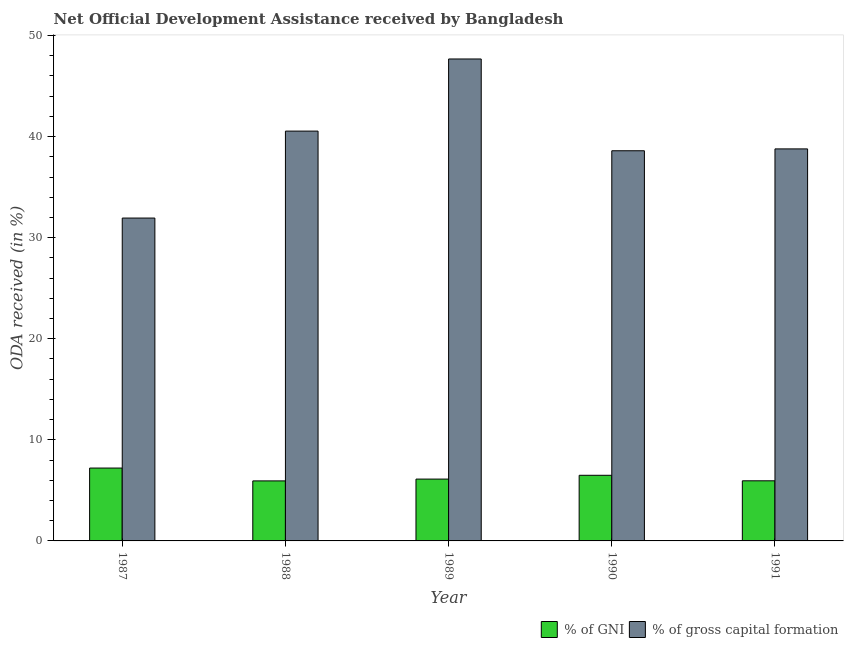How many different coloured bars are there?
Provide a short and direct response. 2. How many groups of bars are there?
Give a very brief answer. 5. How many bars are there on the 1st tick from the right?
Your answer should be very brief. 2. In how many cases, is the number of bars for a given year not equal to the number of legend labels?
Keep it short and to the point. 0. What is the oda received as percentage of gni in 1989?
Make the answer very short. 6.12. Across all years, what is the maximum oda received as percentage of gross capital formation?
Your answer should be very brief. 47.68. Across all years, what is the minimum oda received as percentage of gni?
Provide a succinct answer. 5.94. In which year was the oda received as percentage of gross capital formation maximum?
Ensure brevity in your answer.  1989. In which year was the oda received as percentage of gni minimum?
Your answer should be very brief. 1988. What is the total oda received as percentage of gross capital formation in the graph?
Keep it short and to the point. 197.54. What is the difference between the oda received as percentage of gross capital formation in 1990 and that in 1991?
Keep it short and to the point. -0.18. What is the difference between the oda received as percentage of gni in 1990 and the oda received as percentage of gross capital formation in 1989?
Provide a short and direct response. 0.38. What is the average oda received as percentage of gni per year?
Make the answer very short. 6.34. In the year 1991, what is the difference between the oda received as percentage of gross capital formation and oda received as percentage of gni?
Your answer should be very brief. 0. What is the ratio of the oda received as percentage of gni in 1989 to that in 1990?
Give a very brief answer. 0.94. Is the difference between the oda received as percentage of gni in 1987 and 1990 greater than the difference between the oda received as percentage of gross capital formation in 1987 and 1990?
Keep it short and to the point. No. What is the difference between the highest and the second highest oda received as percentage of gross capital formation?
Provide a succinct answer. 7.14. What is the difference between the highest and the lowest oda received as percentage of gni?
Provide a short and direct response. 1.27. In how many years, is the oda received as percentage of gross capital formation greater than the average oda received as percentage of gross capital formation taken over all years?
Your answer should be compact. 2. Is the sum of the oda received as percentage of gni in 1988 and 1990 greater than the maximum oda received as percentage of gross capital formation across all years?
Provide a short and direct response. Yes. What does the 2nd bar from the left in 1987 represents?
Your answer should be compact. % of gross capital formation. What does the 1st bar from the right in 1991 represents?
Offer a terse response. % of gross capital formation. Are all the bars in the graph horizontal?
Provide a succinct answer. No. Does the graph contain any zero values?
Make the answer very short. No. How many legend labels are there?
Your response must be concise. 2. What is the title of the graph?
Your response must be concise. Net Official Development Assistance received by Bangladesh. What is the label or title of the X-axis?
Your response must be concise. Year. What is the label or title of the Y-axis?
Your answer should be very brief. ODA received (in %). What is the ODA received (in %) in % of GNI in 1987?
Give a very brief answer. 7.21. What is the ODA received (in %) in % of gross capital formation in 1987?
Offer a very short reply. 31.94. What is the ODA received (in %) in % of GNI in 1988?
Make the answer very short. 5.94. What is the ODA received (in %) in % of gross capital formation in 1988?
Provide a succinct answer. 40.54. What is the ODA received (in %) in % of GNI in 1989?
Offer a terse response. 6.12. What is the ODA received (in %) in % of gross capital formation in 1989?
Your answer should be compact. 47.68. What is the ODA received (in %) of % of GNI in 1990?
Provide a succinct answer. 6.49. What is the ODA received (in %) of % of gross capital formation in 1990?
Provide a succinct answer. 38.6. What is the ODA received (in %) of % of GNI in 1991?
Make the answer very short. 5.95. What is the ODA received (in %) in % of gross capital formation in 1991?
Your response must be concise. 38.78. Across all years, what is the maximum ODA received (in %) in % of GNI?
Provide a succinct answer. 7.21. Across all years, what is the maximum ODA received (in %) in % of gross capital formation?
Provide a succinct answer. 47.68. Across all years, what is the minimum ODA received (in %) of % of GNI?
Provide a short and direct response. 5.94. Across all years, what is the minimum ODA received (in %) of % of gross capital formation?
Provide a succinct answer. 31.94. What is the total ODA received (in %) in % of GNI in the graph?
Your answer should be very brief. 31.7. What is the total ODA received (in %) of % of gross capital formation in the graph?
Your answer should be very brief. 197.54. What is the difference between the ODA received (in %) in % of GNI in 1987 and that in 1988?
Offer a terse response. 1.27. What is the difference between the ODA received (in %) in % of gross capital formation in 1987 and that in 1988?
Keep it short and to the point. -8.6. What is the difference between the ODA received (in %) of % of GNI in 1987 and that in 1989?
Give a very brief answer. 1.09. What is the difference between the ODA received (in %) in % of gross capital formation in 1987 and that in 1989?
Offer a terse response. -15.74. What is the difference between the ODA received (in %) of % of GNI in 1987 and that in 1990?
Provide a short and direct response. 0.72. What is the difference between the ODA received (in %) of % of gross capital formation in 1987 and that in 1990?
Provide a succinct answer. -6.66. What is the difference between the ODA received (in %) of % of GNI in 1987 and that in 1991?
Ensure brevity in your answer.  1.26. What is the difference between the ODA received (in %) of % of gross capital formation in 1987 and that in 1991?
Provide a short and direct response. -6.84. What is the difference between the ODA received (in %) in % of GNI in 1988 and that in 1989?
Your response must be concise. -0.18. What is the difference between the ODA received (in %) of % of gross capital formation in 1988 and that in 1989?
Provide a succinct answer. -7.14. What is the difference between the ODA received (in %) in % of GNI in 1988 and that in 1990?
Offer a very short reply. -0.55. What is the difference between the ODA received (in %) in % of gross capital formation in 1988 and that in 1990?
Ensure brevity in your answer.  1.95. What is the difference between the ODA received (in %) of % of GNI in 1988 and that in 1991?
Your answer should be very brief. -0.01. What is the difference between the ODA received (in %) of % of gross capital formation in 1988 and that in 1991?
Make the answer very short. 1.76. What is the difference between the ODA received (in %) of % of GNI in 1989 and that in 1990?
Offer a very short reply. -0.38. What is the difference between the ODA received (in %) of % of gross capital formation in 1989 and that in 1990?
Offer a very short reply. 9.08. What is the difference between the ODA received (in %) in % of GNI in 1989 and that in 1991?
Your answer should be very brief. 0.17. What is the difference between the ODA received (in %) in % of gross capital formation in 1989 and that in 1991?
Provide a short and direct response. 8.9. What is the difference between the ODA received (in %) in % of GNI in 1990 and that in 1991?
Your response must be concise. 0.55. What is the difference between the ODA received (in %) of % of gross capital formation in 1990 and that in 1991?
Offer a very short reply. -0.18. What is the difference between the ODA received (in %) in % of GNI in 1987 and the ODA received (in %) in % of gross capital formation in 1988?
Provide a short and direct response. -33.33. What is the difference between the ODA received (in %) in % of GNI in 1987 and the ODA received (in %) in % of gross capital formation in 1989?
Offer a very short reply. -40.47. What is the difference between the ODA received (in %) of % of GNI in 1987 and the ODA received (in %) of % of gross capital formation in 1990?
Offer a very short reply. -31.39. What is the difference between the ODA received (in %) of % of GNI in 1987 and the ODA received (in %) of % of gross capital formation in 1991?
Offer a terse response. -31.57. What is the difference between the ODA received (in %) of % of GNI in 1988 and the ODA received (in %) of % of gross capital formation in 1989?
Give a very brief answer. -41.74. What is the difference between the ODA received (in %) in % of GNI in 1988 and the ODA received (in %) in % of gross capital formation in 1990?
Ensure brevity in your answer.  -32.66. What is the difference between the ODA received (in %) in % of GNI in 1988 and the ODA received (in %) in % of gross capital formation in 1991?
Your answer should be compact. -32.84. What is the difference between the ODA received (in %) in % of GNI in 1989 and the ODA received (in %) in % of gross capital formation in 1990?
Ensure brevity in your answer.  -32.48. What is the difference between the ODA received (in %) of % of GNI in 1989 and the ODA received (in %) of % of gross capital formation in 1991?
Keep it short and to the point. -32.67. What is the difference between the ODA received (in %) of % of GNI in 1990 and the ODA received (in %) of % of gross capital formation in 1991?
Provide a short and direct response. -32.29. What is the average ODA received (in %) of % of GNI per year?
Your answer should be compact. 6.34. What is the average ODA received (in %) in % of gross capital formation per year?
Ensure brevity in your answer.  39.51. In the year 1987, what is the difference between the ODA received (in %) in % of GNI and ODA received (in %) in % of gross capital formation?
Provide a succinct answer. -24.73. In the year 1988, what is the difference between the ODA received (in %) of % of GNI and ODA received (in %) of % of gross capital formation?
Provide a succinct answer. -34.6. In the year 1989, what is the difference between the ODA received (in %) of % of GNI and ODA received (in %) of % of gross capital formation?
Provide a succinct answer. -41.56. In the year 1990, what is the difference between the ODA received (in %) in % of GNI and ODA received (in %) in % of gross capital formation?
Ensure brevity in your answer.  -32.11. In the year 1991, what is the difference between the ODA received (in %) of % of GNI and ODA received (in %) of % of gross capital formation?
Ensure brevity in your answer.  -32.84. What is the ratio of the ODA received (in %) in % of GNI in 1987 to that in 1988?
Make the answer very short. 1.21. What is the ratio of the ODA received (in %) of % of gross capital formation in 1987 to that in 1988?
Give a very brief answer. 0.79. What is the ratio of the ODA received (in %) in % of GNI in 1987 to that in 1989?
Provide a succinct answer. 1.18. What is the ratio of the ODA received (in %) in % of gross capital formation in 1987 to that in 1989?
Keep it short and to the point. 0.67. What is the ratio of the ODA received (in %) of % of GNI in 1987 to that in 1990?
Your answer should be compact. 1.11. What is the ratio of the ODA received (in %) in % of gross capital formation in 1987 to that in 1990?
Offer a terse response. 0.83. What is the ratio of the ODA received (in %) of % of GNI in 1987 to that in 1991?
Provide a short and direct response. 1.21. What is the ratio of the ODA received (in %) in % of gross capital formation in 1987 to that in 1991?
Keep it short and to the point. 0.82. What is the ratio of the ODA received (in %) in % of GNI in 1988 to that in 1989?
Keep it short and to the point. 0.97. What is the ratio of the ODA received (in %) in % of gross capital formation in 1988 to that in 1989?
Give a very brief answer. 0.85. What is the ratio of the ODA received (in %) in % of GNI in 1988 to that in 1990?
Give a very brief answer. 0.91. What is the ratio of the ODA received (in %) of % of gross capital formation in 1988 to that in 1990?
Your answer should be compact. 1.05. What is the ratio of the ODA received (in %) in % of gross capital formation in 1988 to that in 1991?
Provide a succinct answer. 1.05. What is the ratio of the ODA received (in %) of % of GNI in 1989 to that in 1990?
Provide a succinct answer. 0.94. What is the ratio of the ODA received (in %) in % of gross capital formation in 1989 to that in 1990?
Provide a short and direct response. 1.24. What is the ratio of the ODA received (in %) in % of GNI in 1989 to that in 1991?
Provide a succinct answer. 1.03. What is the ratio of the ODA received (in %) in % of gross capital formation in 1989 to that in 1991?
Offer a terse response. 1.23. What is the ratio of the ODA received (in %) in % of GNI in 1990 to that in 1991?
Ensure brevity in your answer.  1.09. What is the ratio of the ODA received (in %) in % of gross capital formation in 1990 to that in 1991?
Keep it short and to the point. 1. What is the difference between the highest and the second highest ODA received (in %) in % of GNI?
Offer a very short reply. 0.72. What is the difference between the highest and the second highest ODA received (in %) in % of gross capital formation?
Your answer should be very brief. 7.14. What is the difference between the highest and the lowest ODA received (in %) in % of GNI?
Provide a short and direct response. 1.27. What is the difference between the highest and the lowest ODA received (in %) of % of gross capital formation?
Your answer should be very brief. 15.74. 